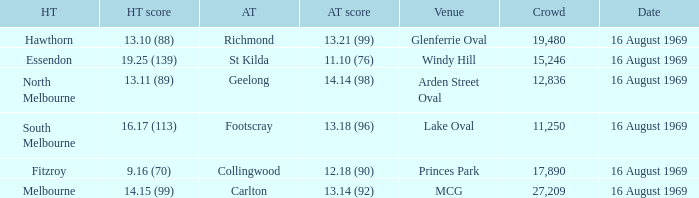Could you parse the entire table? {'header': ['HT', 'HT score', 'AT', 'AT score', 'Venue', 'Crowd', 'Date'], 'rows': [['Hawthorn', '13.10 (88)', 'Richmond', '13.21 (99)', 'Glenferrie Oval', '19,480', '16 August 1969'], ['Essendon', '19.25 (139)', 'St Kilda', '11.10 (76)', 'Windy Hill', '15,246', '16 August 1969'], ['North Melbourne', '13.11 (89)', 'Geelong', '14.14 (98)', 'Arden Street Oval', '12,836', '16 August 1969'], ['South Melbourne', '16.17 (113)', 'Footscray', '13.18 (96)', 'Lake Oval', '11,250', '16 August 1969'], ['Fitzroy', '9.16 (70)', 'Collingwood', '12.18 (90)', 'Princes Park', '17,890', '16 August 1969'], ['Melbourne', '14.15 (99)', 'Carlton', '13.14 (92)', 'MCG', '27,209', '16 August 1969']]} What was the away team when the game was at Princes Park? Collingwood. 